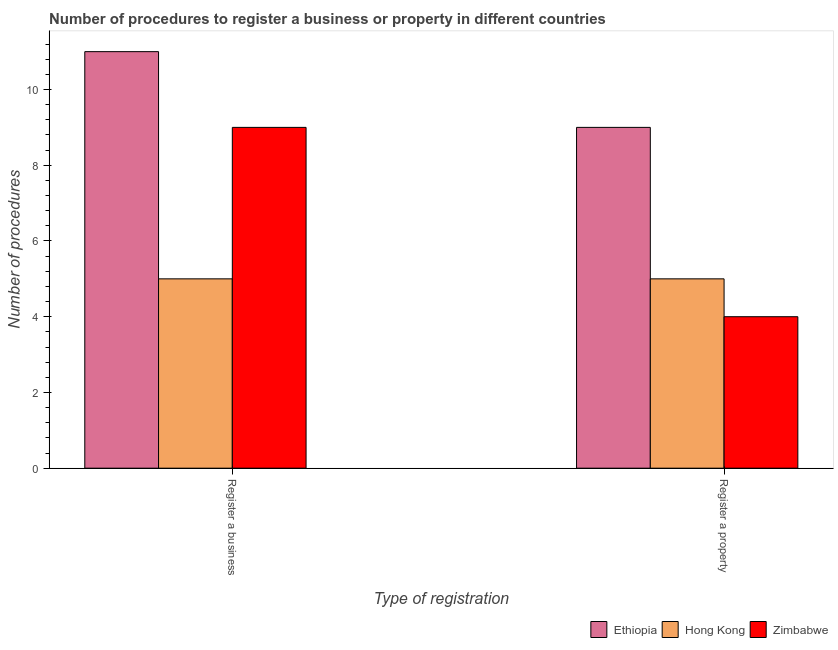Are the number of bars per tick equal to the number of legend labels?
Offer a very short reply. Yes. How many bars are there on the 1st tick from the left?
Make the answer very short. 3. How many bars are there on the 1st tick from the right?
Offer a terse response. 3. What is the label of the 2nd group of bars from the left?
Your answer should be very brief. Register a property. What is the number of procedures to register a property in Ethiopia?
Offer a very short reply. 9. Across all countries, what is the maximum number of procedures to register a business?
Make the answer very short. 11. Across all countries, what is the minimum number of procedures to register a property?
Your response must be concise. 4. In which country was the number of procedures to register a property maximum?
Make the answer very short. Ethiopia. In which country was the number of procedures to register a property minimum?
Provide a succinct answer. Zimbabwe. What is the total number of procedures to register a property in the graph?
Your response must be concise. 18. What is the difference between the number of procedures to register a business in Ethiopia and that in Zimbabwe?
Offer a very short reply. 2. What is the difference between the number of procedures to register a business in Hong Kong and the number of procedures to register a property in Zimbabwe?
Your answer should be very brief. 1. What is the average number of procedures to register a business per country?
Offer a terse response. 8.33. What is the difference between the number of procedures to register a business and number of procedures to register a property in Zimbabwe?
Offer a very short reply. 5. What is the ratio of the number of procedures to register a business in Ethiopia to that in Zimbabwe?
Provide a succinct answer. 1.22. What does the 1st bar from the left in Register a business represents?
Offer a very short reply. Ethiopia. What does the 1st bar from the right in Register a business represents?
Give a very brief answer. Zimbabwe. How many bars are there?
Make the answer very short. 6. What is the difference between two consecutive major ticks on the Y-axis?
Make the answer very short. 2. Does the graph contain grids?
Provide a succinct answer. No. What is the title of the graph?
Offer a terse response. Number of procedures to register a business or property in different countries. Does "Antigua and Barbuda" appear as one of the legend labels in the graph?
Your answer should be very brief. No. What is the label or title of the X-axis?
Ensure brevity in your answer.  Type of registration. What is the label or title of the Y-axis?
Make the answer very short. Number of procedures. What is the Number of procedures of Ethiopia in Register a business?
Give a very brief answer. 11. What is the Number of procedures in Hong Kong in Register a business?
Keep it short and to the point. 5. What is the Number of procedures of Zimbabwe in Register a business?
Keep it short and to the point. 9. What is the Number of procedures of Hong Kong in Register a property?
Your answer should be very brief. 5. What is the Number of procedures in Zimbabwe in Register a property?
Make the answer very short. 4. Across all Type of registration, what is the maximum Number of procedures of Zimbabwe?
Ensure brevity in your answer.  9. Across all Type of registration, what is the minimum Number of procedures of Ethiopia?
Give a very brief answer. 9. Across all Type of registration, what is the minimum Number of procedures of Hong Kong?
Offer a very short reply. 5. What is the difference between the Number of procedures of Ethiopia in Register a business and the Number of procedures of Zimbabwe in Register a property?
Your response must be concise. 7. What is the difference between the Number of procedures in Hong Kong in Register a business and the Number of procedures in Zimbabwe in Register a property?
Your answer should be very brief. 1. What is the average Number of procedures in Zimbabwe per Type of registration?
Provide a succinct answer. 6.5. What is the difference between the Number of procedures of Ethiopia and Number of procedures of Hong Kong in Register a business?
Your answer should be compact. 6. What is the difference between the Number of procedures in Ethiopia and Number of procedures in Zimbabwe in Register a business?
Your answer should be very brief. 2. What is the difference between the Number of procedures in Ethiopia and Number of procedures in Hong Kong in Register a property?
Provide a succinct answer. 4. What is the difference between the Number of procedures of Ethiopia and Number of procedures of Zimbabwe in Register a property?
Offer a terse response. 5. What is the difference between the Number of procedures of Hong Kong and Number of procedures of Zimbabwe in Register a property?
Keep it short and to the point. 1. What is the ratio of the Number of procedures in Ethiopia in Register a business to that in Register a property?
Provide a succinct answer. 1.22. What is the ratio of the Number of procedures in Zimbabwe in Register a business to that in Register a property?
Give a very brief answer. 2.25. What is the difference between the highest and the second highest Number of procedures of Hong Kong?
Offer a terse response. 0. What is the difference between the highest and the lowest Number of procedures of Ethiopia?
Make the answer very short. 2. What is the difference between the highest and the lowest Number of procedures of Zimbabwe?
Your response must be concise. 5. 